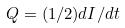Convert formula to latex. <formula><loc_0><loc_0><loc_500><loc_500>Q = ( 1 / 2 ) d I / d t</formula> 